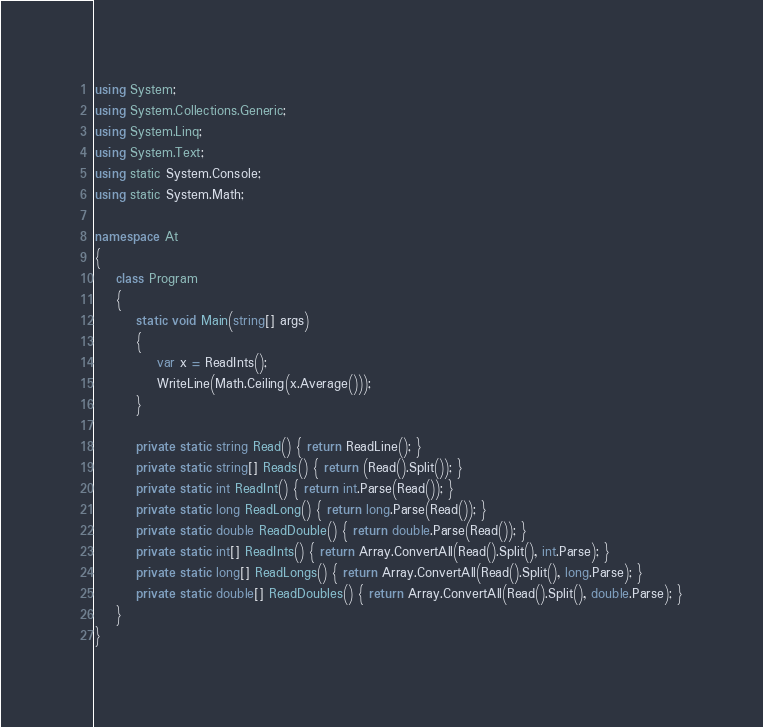<code> <loc_0><loc_0><loc_500><loc_500><_C#_>using System;
using System.Collections.Generic;
using System.Linq;
using System.Text;
using static System.Console;
using static System.Math;

namespace At
{
    class Program
    {
        static void Main(string[] args)
        {
            var x = ReadInts();
            WriteLine(Math.Ceiling(x.Average()));
        }

        private static string Read() { return ReadLine(); }
        private static string[] Reads() { return (Read().Split()); }
        private static int ReadInt() { return int.Parse(Read()); }
        private static long ReadLong() { return long.Parse(Read()); }
        private static double ReadDouble() { return double.Parse(Read()); }
        private static int[] ReadInts() { return Array.ConvertAll(Read().Split(), int.Parse); }
        private static long[] ReadLongs() { return Array.ConvertAll(Read().Split(), long.Parse); }
        private static double[] ReadDoubles() { return Array.ConvertAll(Read().Split(), double.Parse); }
    }
}
</code> 